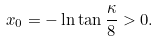<formula> <loc_0><loc_0><loc_500><loc_500>x _ { 0 } = - \ln \tan \frac { \kappa } { 8 } > 0 .</formula> 